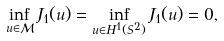Convert formula to latex. <formula><loc_0><loc_0><loc_500><loc_500>\inf _ { u \in { \mathcal { M } } } J _ { 1 } ( u ) = \inf _ { u \in H ^ { 1 } ( S ^ { 2 } ) } J _ { 1 } ( u ) = 0 ,</formula> 